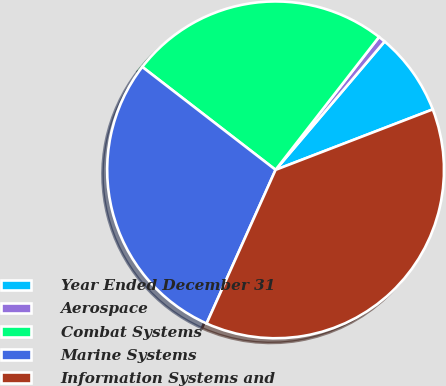<chart> <loc_0><loc_0><loc_500><loc_500><pie_chart><fcel>Year Ended December 31<fcel>Aerospace<fcel>Combat Systems<fcel>Marine Systems<fcel>Information Systems and<nl><fcel>7.95%<fcel>0.68%<fcel>25.06%<fcel>28.75%<fcel>37.56%<nl></chart> 